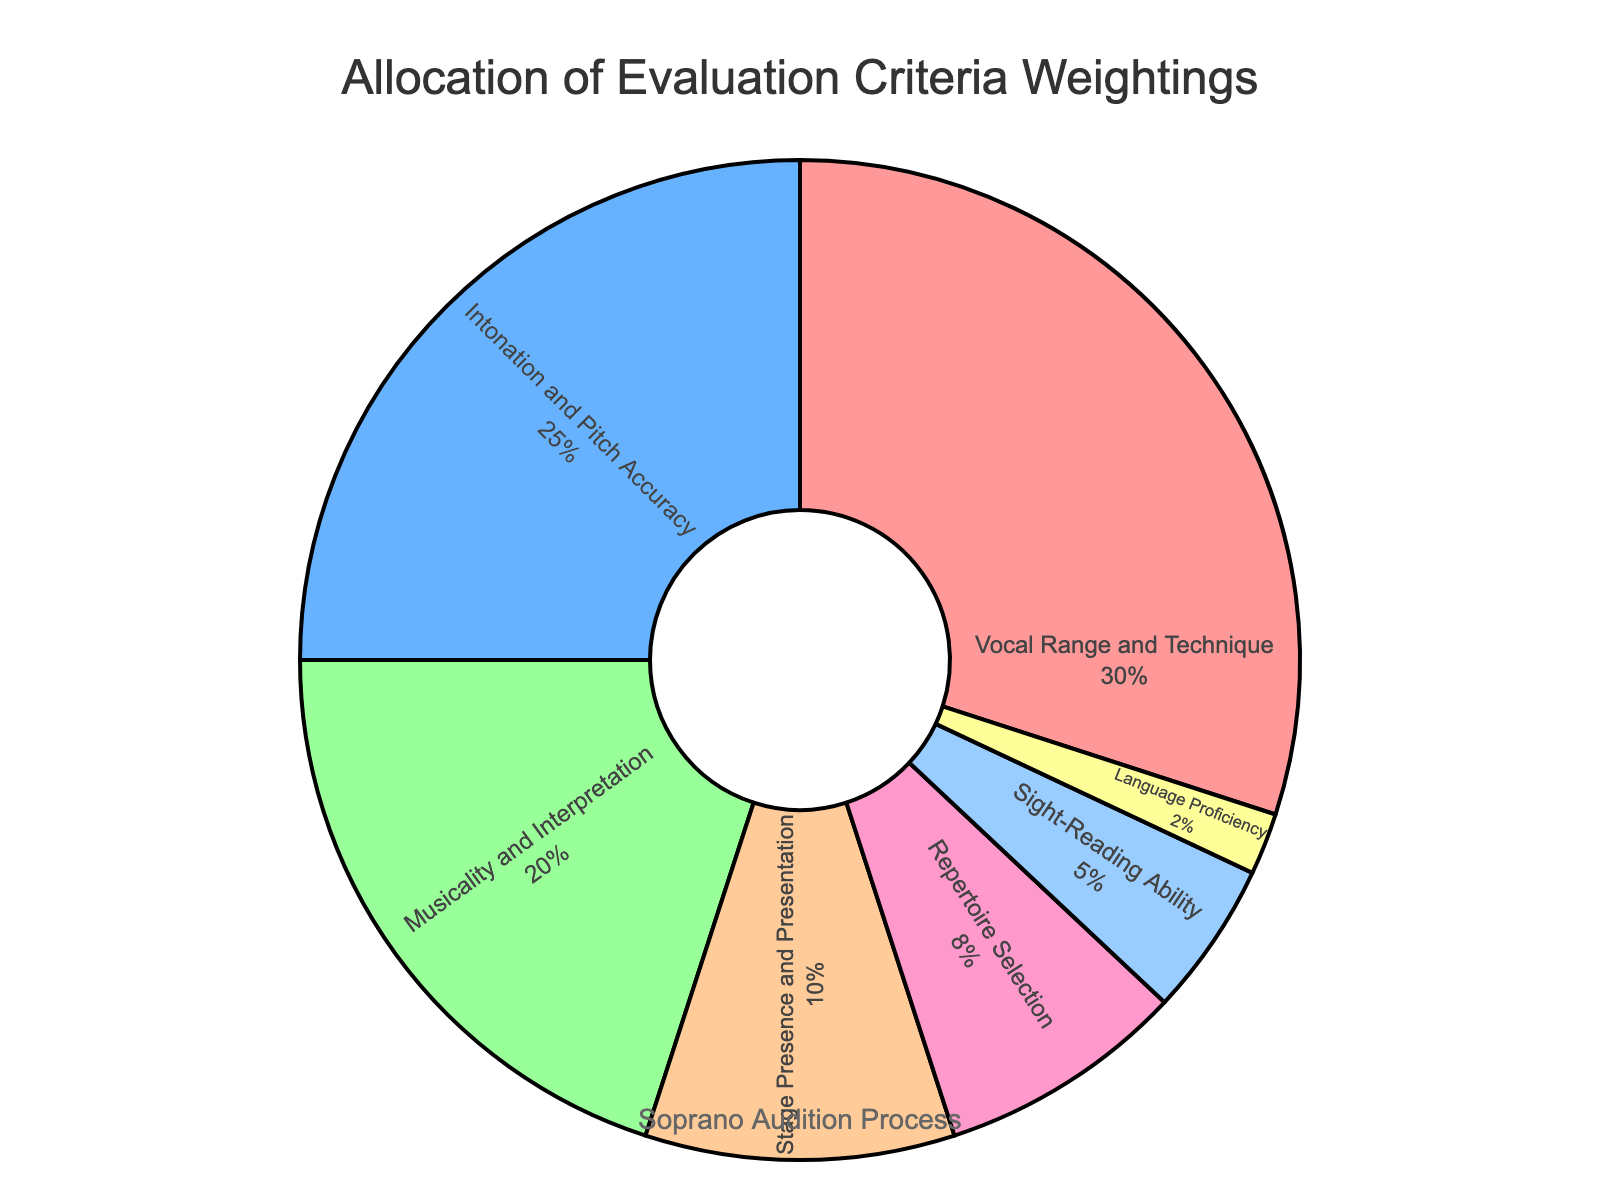What percentage of the evaluation criteria is allocated to Vocal Range and Technique? The slice representing Vocal Range and Technique has a label with the percentage value inside it. By looking at the label, we can see that it is 30%.
Answer: 30% Which category gets more weightage, Intonation and Pitch Accuracy or Stage Presence and Presentation? Compare the size of the pie slices labeled Intonation and Pitch Accuracy and Stage Presence and Presentation. The one with a higher percentage indicates greater weightage. Intonation and Pitch Accuracy has 25%, while Stage Presence and Presentation has 10%.
Answer: Intonation and Pitch Accuracy What is the combined percentage of Repertoire Selection and Sight-Reading Ability? Add the percentages of Repertoire Selection and Sight-Reading Ability from the figure. Repertoire Selection is 8% and Sight-Reading Ability is 5%. Therefore, the combined percentage is 8% + 5% = 13%.
Answer: 13% Which two categories together make up half of the evaluation criteria? Identify two categories whose percentages add up to 50%. The largest two categories are Vocal Range and Technique (30%) and Intonation and Pitch Accuracy (25%), which together is 30% + 25% = 55%. However, the correct combination is Vocal Range and Technique (30%) and Musicality and Interpretation (20%) which together is 30% + 20% = 50%.
Answer: Vocal Range and Technique, Musicality and Interpretation Is Repertoire Selection allocated more or less than one-fourth of the weight assigned to Vocal Range and Technique? Calculate one-fourth of Vocal Range and Technique's percentage (30%). One-fourth is 30% / 4 = 7.5%. Compare this with Repertoire Selection's percentage (8%). Since 8% is greater than 7.5%, Repertoire Selection is allocated more.
Answer: More What fraction of the total weight is allocated to Language Proficiency? The total percentage should add up to 100%. Language Proficiency has 2%, so the fraction of the total weight is 2/100, which simplifies to 1/50.
Answer: 1/50 By what margin does Stage Presence and Presentation exceed Sight-Reading Ability? Subtract the percentage allocated to Sight-Reading Ability from that of Stage Presence and Presentation. Stage Presence and Presentation is 10%, and Sight-Reading Ability is 5%, so the margin is 10% - 5% = 5%.
Answer: 5% Considering the top three categories, what is their combined percentage allocation? Sum the percentages of the top three categories: Vocal Range and Technique (30%), Intonation and Pitch Accuracy (25%), and Musicality and Interpretation (20%). Their combined percentage is 30% + 25% + 20% = 75%.
Answer: 75% Which category has the smallest allocation and what is its percentage? Identify the smallest slice in the pie chart. The label inside the smallest slice indicates Language Proficiency with 2%.
Answer: Language Proficiency, 2% 